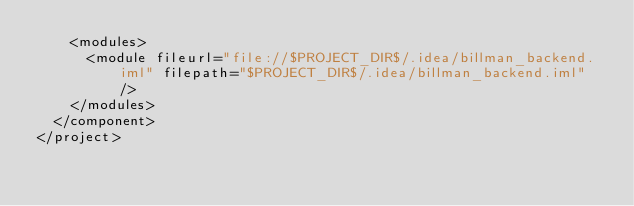<code> <loc_0><loc_0><loc_500><loc_500><_XML_>    <modules>
      <module fileurl="file://$PROJECT_DIR$/.idea/billman_backend.iml" filepath="$PROJECT_DIR$/.idea/billman_backend.iml" />
    </modules>
  </component>
</project></code> 